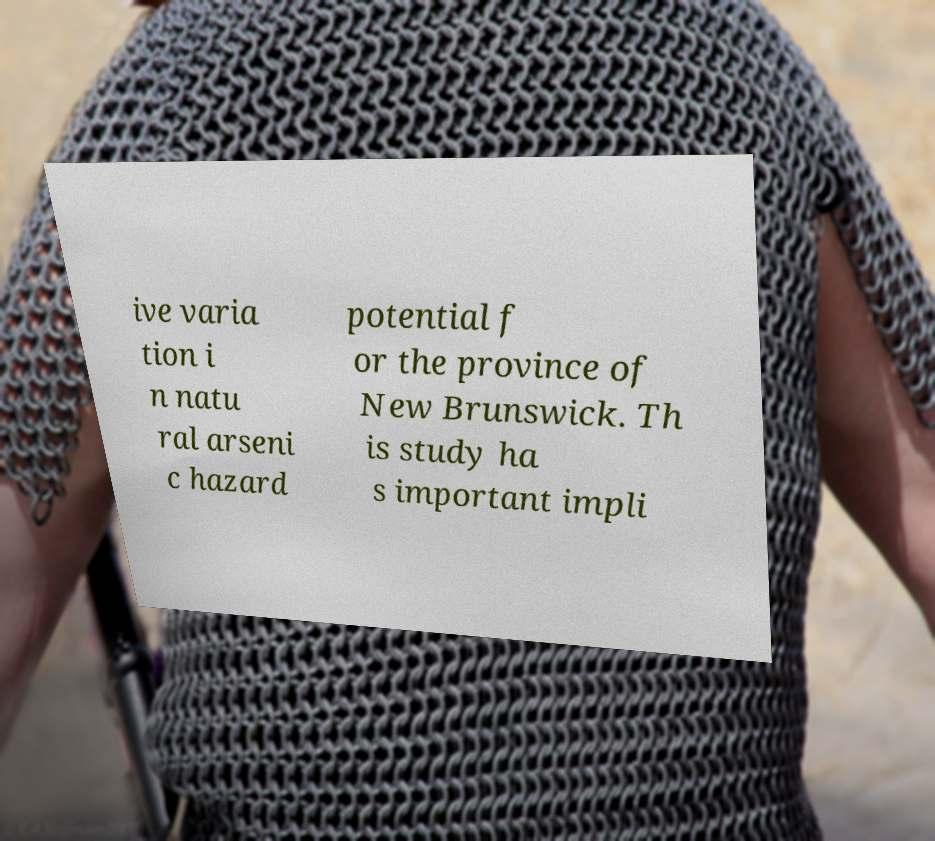Please read and relay the text visible in this image. What does it say? ive varia tion i n natu ral arseni c hazard potential f or the province of New Brunswick. Th is study ha s important impli 